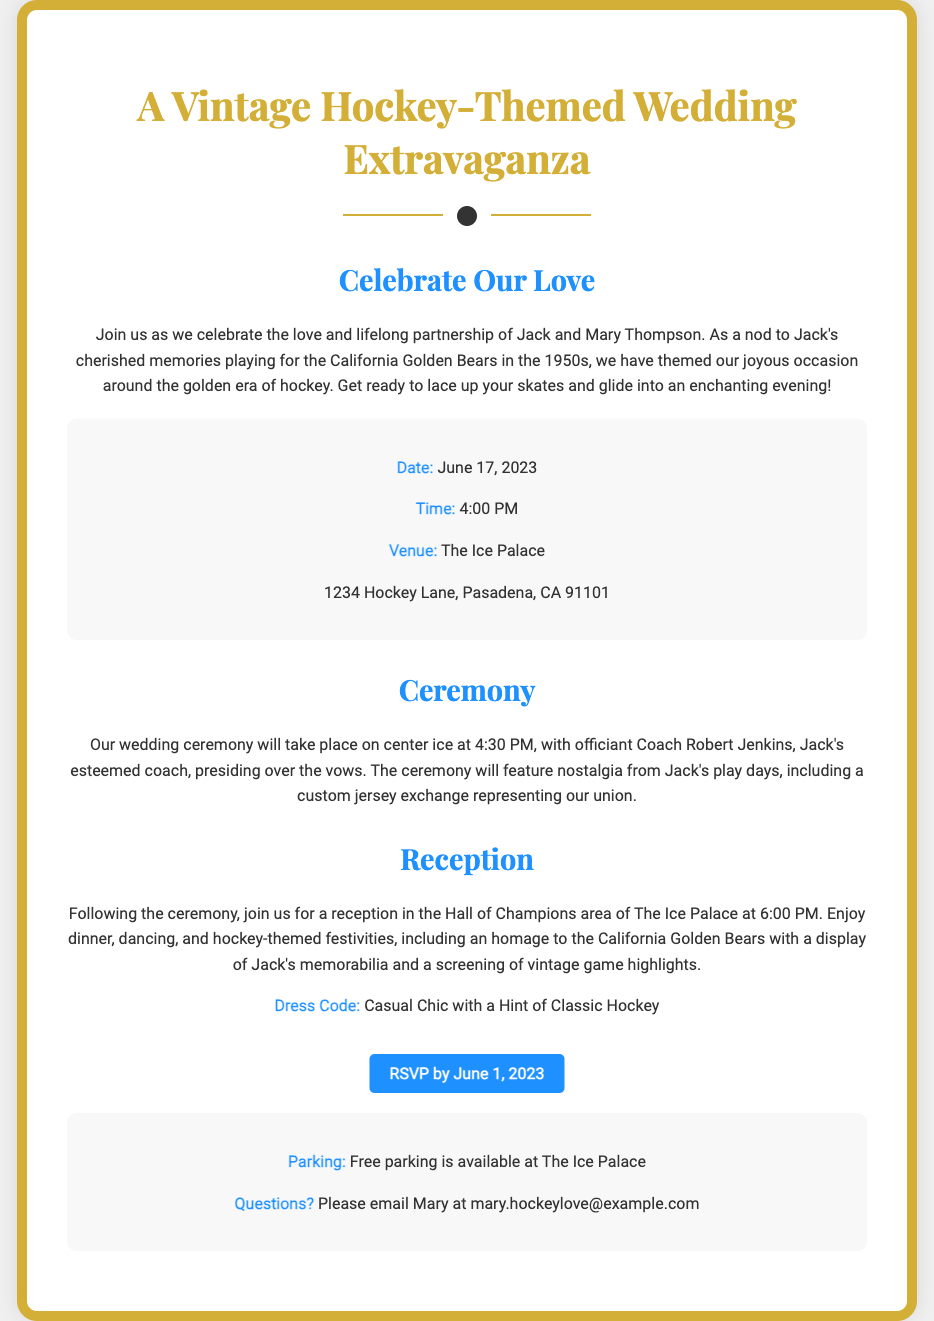What is the couple's names? The couple's names are mentioned in the document in the introduction.
Answer: Jack and Mary Thompson What is the wedding date? The wedding date is clearly listed in the details section of the document.
Answer: June 17, 2023 What time does the ceremony start? The ceremony start time is specified shortly after the information about the wedding date and venue.
Answer: 4:30 PM Where is the wedding venue? The venue address is provided in the details section of the invitation.
Answer: The Ice Palace, 1234 Hockey Lane, Pasadena, CA 91101 What is the dress code for the wedding? The dress code is highlighted in the reception section of the document.
Answer: Casual Chic with a Hint of Classic Hockey Who is officiating the ceremony? The officiant's name is mentioned in the ceremony section along with their relation to Jack.
Answer: Coach Robert Jenkins What time does the reception start? The reception start time is listed after the ceremony information.
Answer: 6:00 PM What special feature will be included in the ceremony? A specific tradition related to Jack's past is described in the ceremony section.
Answer: Custom jersey exchange What is provided for parking? The parking information can be found in the details section.
Answer: Free parking What is the RSVP deadline? The RSVP deadline is indicated in the call to action near the end of the invitation.
Answer: June 1, 2023 